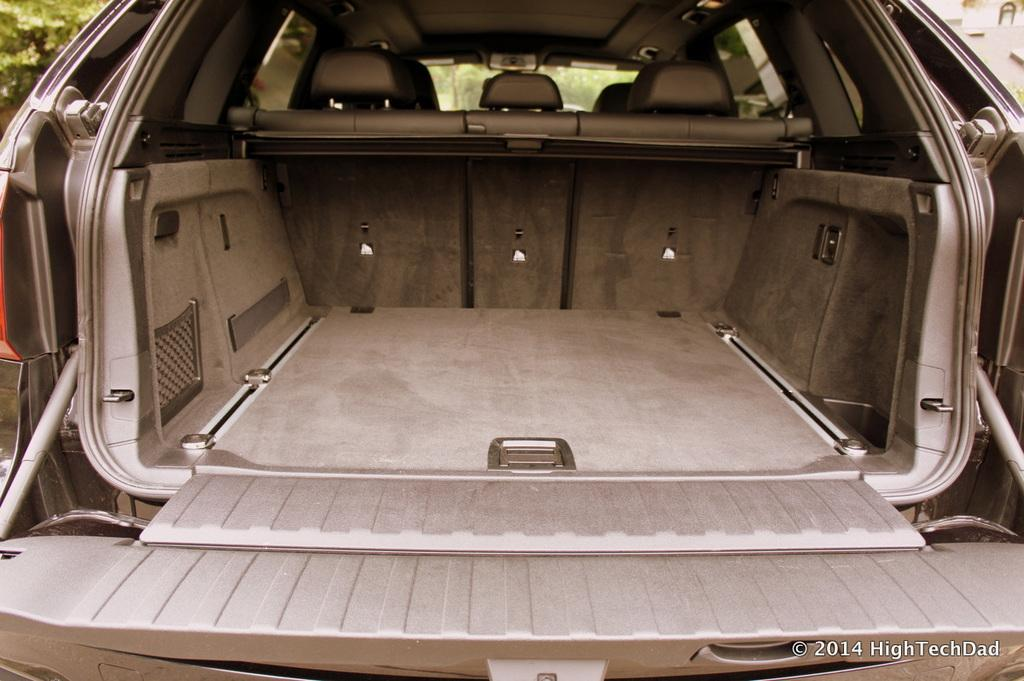What type of vehicle is shown in the image? The image shows an inside view of a car. What can be seen through the front of the car? There is a windshield visible in the image, and trees are visible through it. What type of tramp is visible in the image? There is no tramp present in the image; it shows an inside view of a car with a windshield and trees visible through it. 